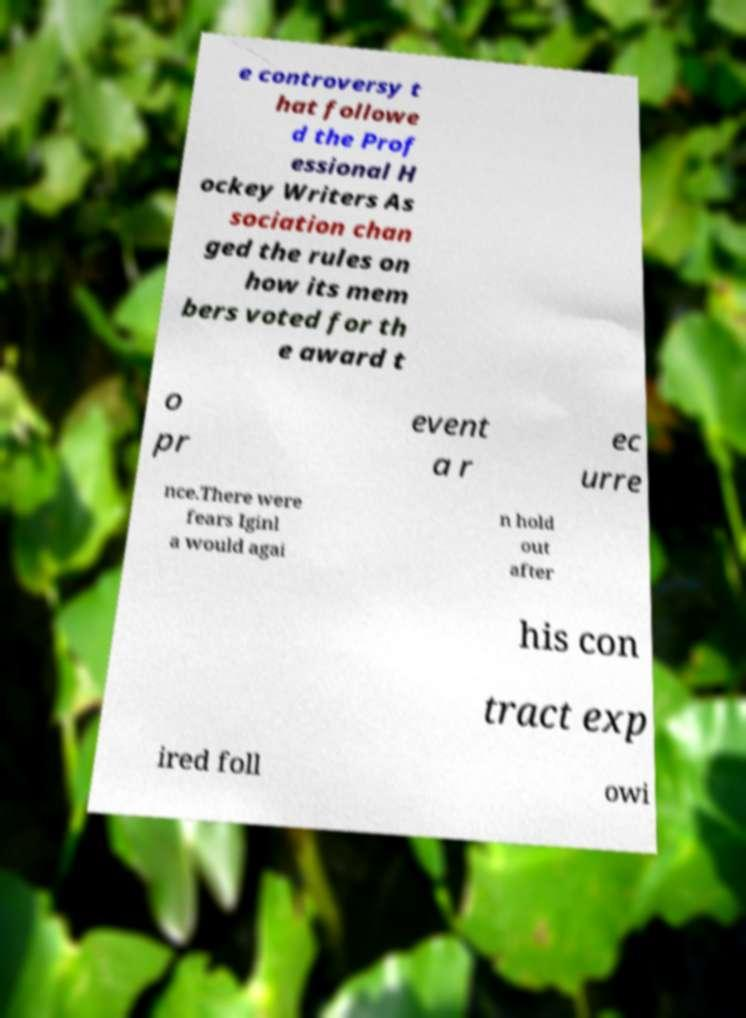What messages or text are displayed in this image? I need them in a readable, typed format. e controversy t hat followe d the Prof essional H ockey Writers As sociation chan ged the rules on how its mem bers voted for th e award t o pr event a r ec urre nce.There were fears Iginl a would agai n hold out after his con tract exp ired foll owi 